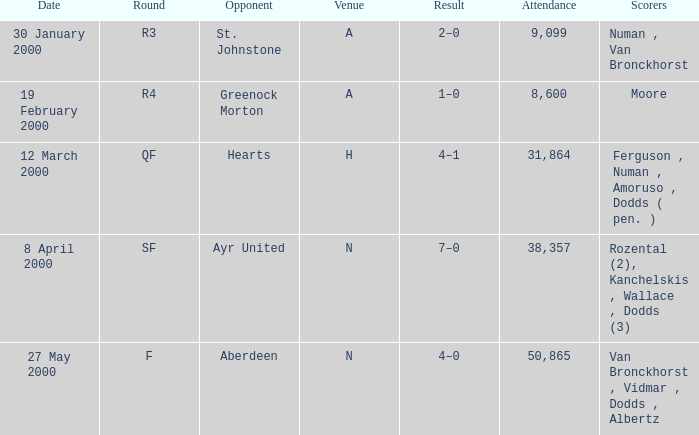Who was in a against competitor st. johnstone? Numan , Van Bronckhorst. 